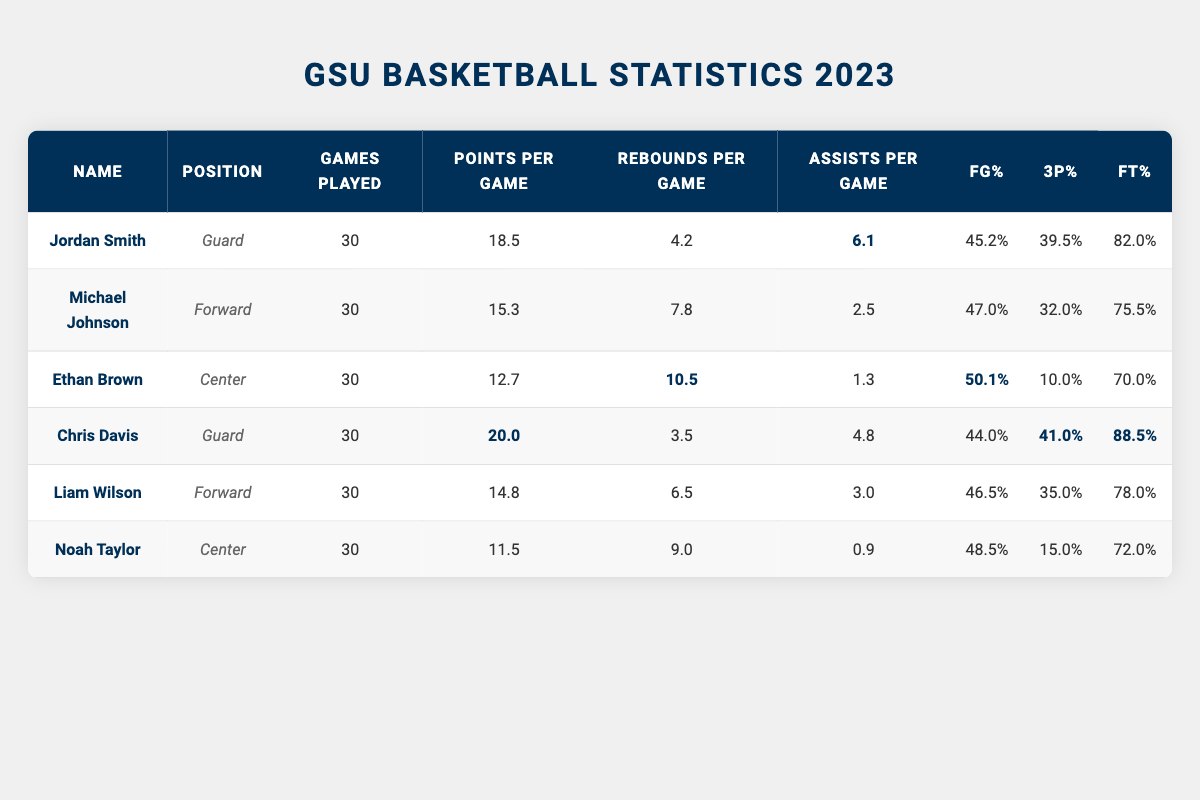What is the player with the highest points per game? By reviewing the "Points Per Game" column, Chris Davis has the highest points per game at 20.0 compared to others like Jordan Smith at 18.5.
Answer: Chris Davis What is the average number of rebounds per game by the players? To find the average, add all the rebounds per game: 4.2 + 7.8 + 10.5 + 3.5 + 6.5 + 9.0 = 41.5. Since there are 6 players, divide 41.5 by 6, resulting in approximately 6.92.
Answer: 6.92 Which player has the best free throw percentage? By looking at the "Free Throw Percentage" column, Chris Davis has the highest free throw percentage at 88.5%.
Answer: Chris Davis Which player has the lowest three-point percentage? Checking the "Three Point Percentage" column, Ethan Brown has the lowest three-point percentage at 10.0%.
Answer: Ethan Brown How many total assists did all players average per game? First, sum the assists per game: 6.1 + 2.5 + 1.3 + 4.8 + 3.0 + 0.9 = 18.6. With 6 players, divide 18.6 by 6 to find an average of 3.1.
Answer: 3.1 Is Michael Johnson more effective in field goal shooting than Noah Taylor? Comparing the "Field Goal Percentage" for both players, Michael Johnson is at 47.0%, while Noah Taylor is at 48.5%. Thus, Noah Taylor has a higher percentage.
Answer: No If we were to rank the players based on their points per game, who would be in the second place? Listing the points per game: Chris Davis (20.0), Jordan Smith (18.5), Michael Johnson (15.3), Liam Wilson (14.8), Ethan Brown (12.7), Noah Taylor (11.5), Jordan Smith comes in second after Chris Davis.
Answer: Jordan Smith What is the difference in rebounds per game between Jordan Smith and Liam Wilson? Jordan Smith averages 4.2 rebounds per game, while Liam Wilson averages 6.5. The difference is calculated as 6.5 - 4.2 = 2.3.
Answer: 2.3 Which center had the highest points per game? The centers are Ethan Brown and Noah Taylor; Ethan Brown scores 12.7 points per game, and Noah Taylor scores 11.5. Hence, Ethan Brown has the higher score.
Answer: Ethan Brown Are there any players with over 40% three-point shooting? Upon reviewing the "Three Point Percentage," Chris Davis at 41.0% and Jordan Smith at 39.5% are over 40%. This is true.
Answer: Yes 